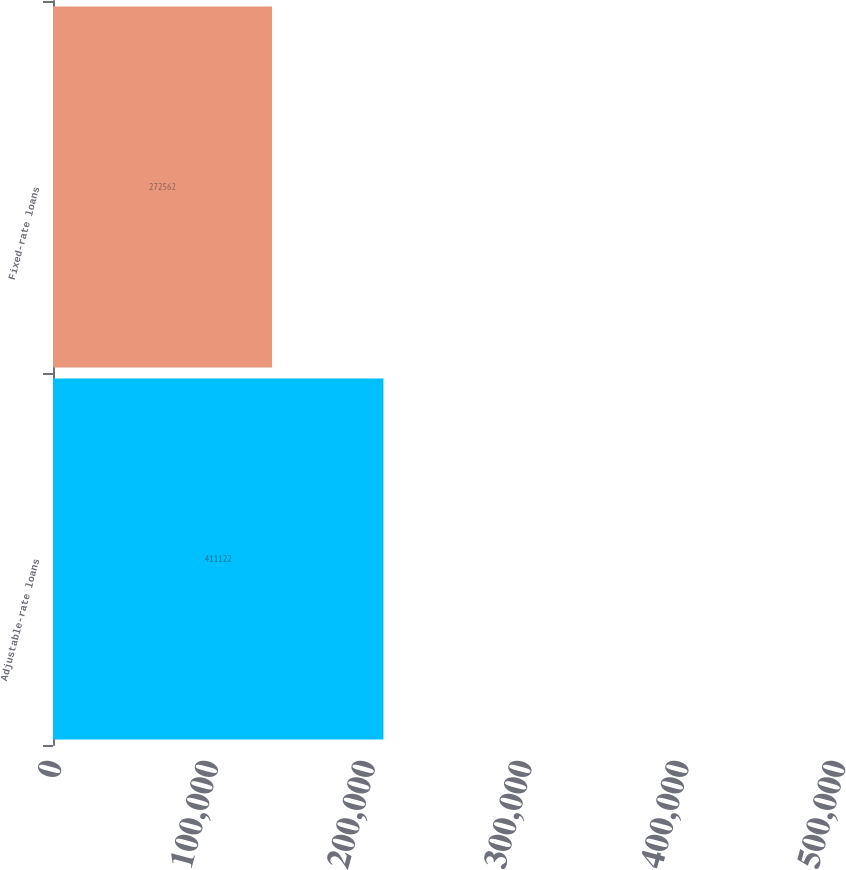<chart> <loc_0><loc_0><loc_500><loc_500><bar_chart><fcel>Adjustable-rate loans<fcel>Fixed-rate loans<nl><fcel>411122<fcel>272562<nl></chart> 